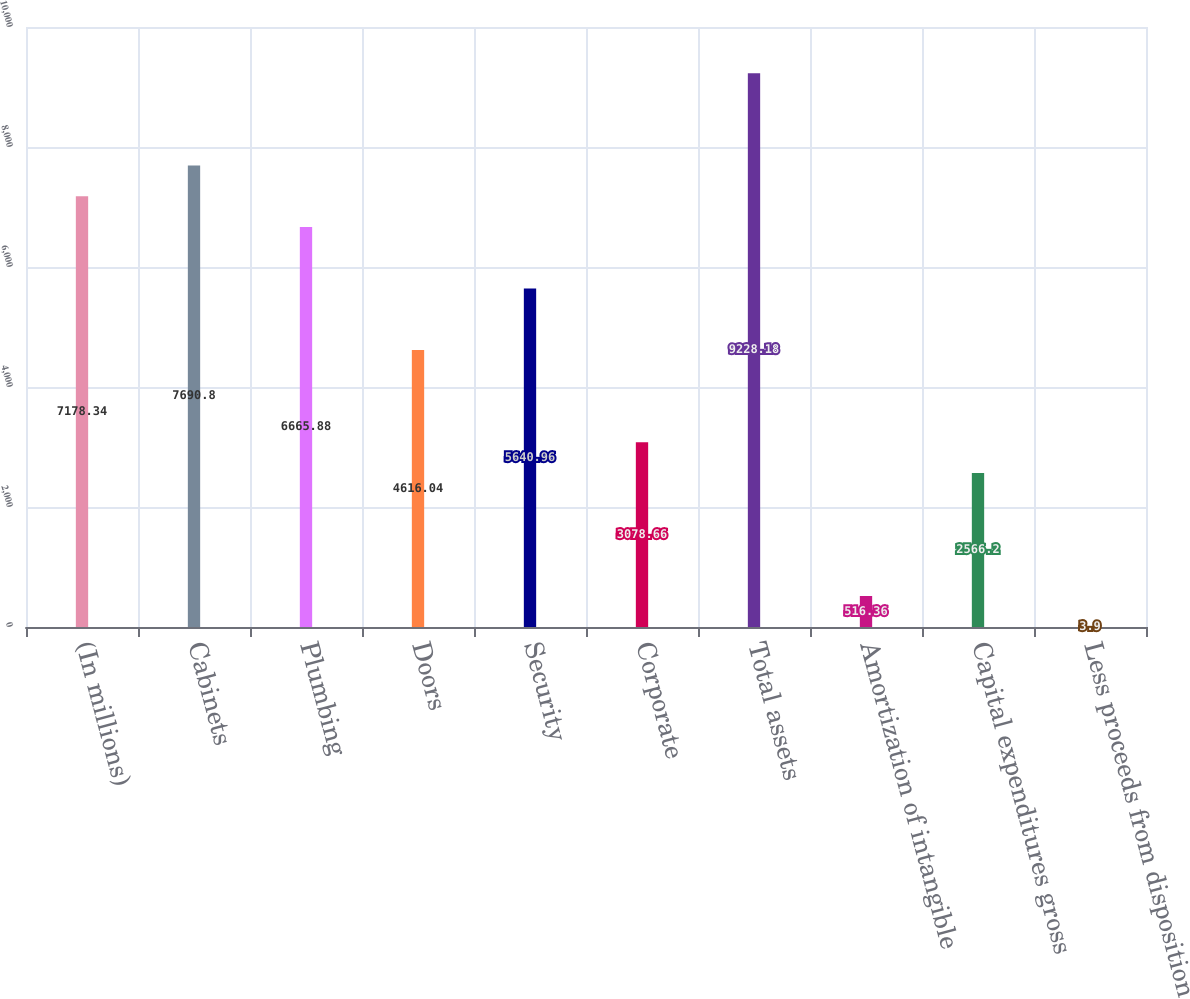Convert chart to OTSL. <chart><loc_0><loc_0><loc_500><loc_500><bar_chart><fcel>(In millions)<fcel>Cabinets<fcel>Plumbing<fcel>Doors<fcel>Security<fcel>Corporate<fcel>Total assets<fcel>Amortization of intangible<fcel>Capital expenditures gross<fcel>Less proceeds from disposition<nl><fcel>7178.34<fcel>7690.8<fcel>6665.88<fcel>4616.04<fcel>5640.96<fcel>3078.66<fcel>9228.18<fcel>516.36<fcel>2566.2<fcel>3.9<nl></chart> 